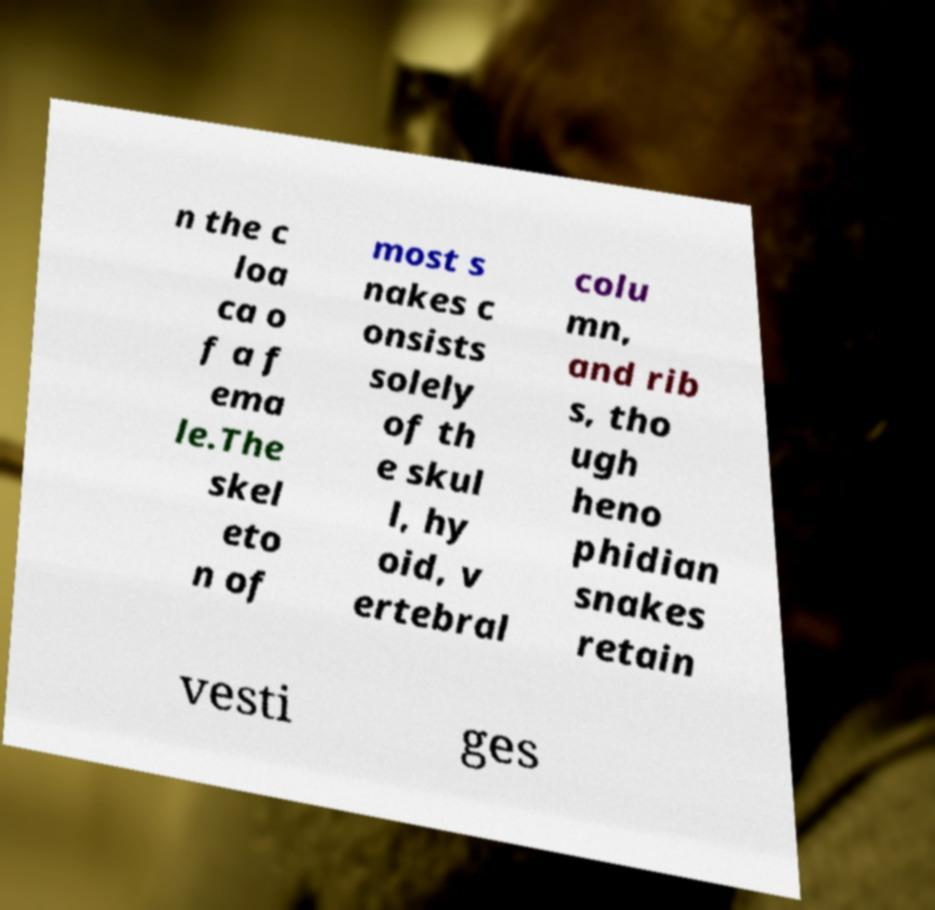What messages or text are displayed in this image? I need them in a readable, typed format. n the c loa ca o f a f ema le.The skel eto n of most s nakes c onsists solely of th e skul l, hy oid, v ertebral colu mn, and rib s, tho ugh heno phidian snakes retain vesti ges 